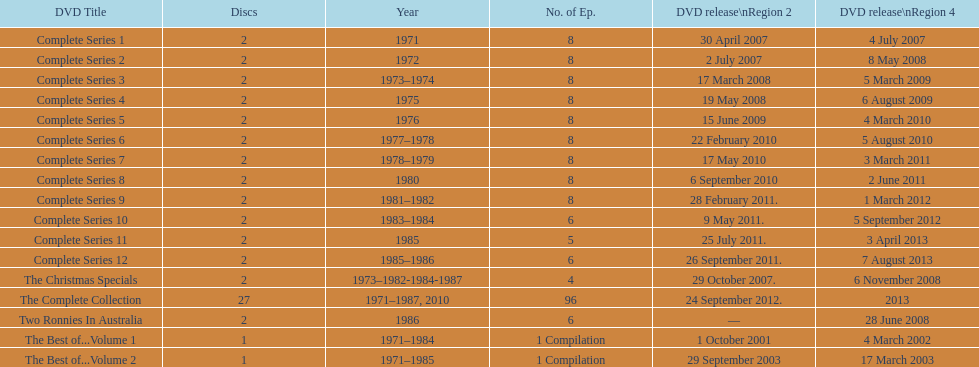The complete collection has 96 episodes, but the christmas specials only has how many episodes? 4. 